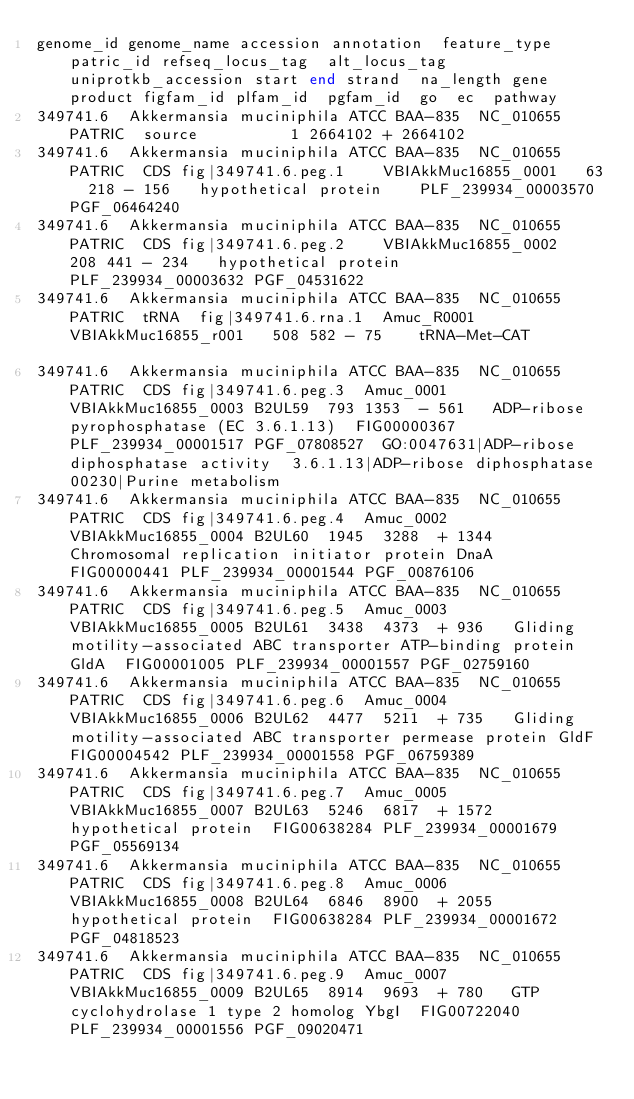<code> <loc_0><loc_0><loc_500><loc_500><_SQL_>genome_id	genome_name	accession	annotation	feature_type	patric_id	refseq_locus_tag	alt_locus_tag	uniprotkb_accession	start	end	strand	na_length	gene	product	figfam_id	plfam_id	pgfam_id	go	ec	pathway
349741.6	Akkermansia muciniphila ATCC BAA-835	NC_010655	PATRIC	source					1	2664102	+	2664102								
349741.6	Akkermansia muciniphila ATCC BAA-835	NC_010655	PATRIC	CDS	fig|349741.6.peg.1		VBIAkkMuc16855_0001		63	218	-	156		hypothetical protein		PLF_239934_00003570	PGF_06464240			
349741.6	Akkermansia muciniphila ATCC BAA-835	NC_010655	PATRIC	CDS	fig|349741.6.peg.2		VBIAkkMuc16855_0002		208	441	-	234		hypothetical protein		PLF_239934_00003632	PGF_04531622			
349741.6	Akkermansia muciniphila ATCC BAA-835	NC_010655	PATRIC	tRNA	fig|349741.6.rna.1	Amuc_R0001	VBIAkkMuc16855_r001		508	582	-	75		tRNA-Met-CAT						
349741.6	Akkermansia muciniphila ATCC BAA-835	NC_010655	PATRIC	CDS	fig|349741.6.peg.3	Amuc_0001	VBIAkkMuc16855_0003	B2UL59	793	1353	-	561		ADP-ribose pyrophosphatase (EC 3.6.1.13)	FIG00000367	PLF_239934_00001517	PGF_07808527	GO:0047631|ADP-ribose diphosphatase activity	3.6.1.13|ADP-ribose diphosphatase	00230|Purine metabolism
349741.6	Akkermansia muciniphila ATCC BAA-835	NC_010655	PATRIC	CDS	fig|349741.6.peg.4	Amuc_0002	VBIAkkMuc16855_0004	B2UL60	1945	3288	+	1344		Chromosomal replication initiator protein DnaA	FIG00000441	PLF_239934_00001544	PGF_00876106			
349741.6	Akkermansia muciniphila ATCC BAA-835	NC_010655	PATRIC	CDS	fig|349741.6.peg.5	Amuc_0003	VBIAkkMuc16855_0005	B2UL61	3438	4373	+	936		Gliding motility-associated ABC transporter ATP-binding protein GldA	FIG00001005	PLF_239934_00001557	PGF_02759160			
349741.6	Akkermansia muciniphila ATCC BAA-835	NC_010655	PATRIC	CDS	fig|349741.6.peg.6	Amuc_0004	VBIAkkMuc16855_0006	B2UL62	4477	5211	+	735		Gliding motility-associated ABC transporter permease protein GldF	FIG00004542	PLF_239934_00001558	PGF_06759389			
349741.6	Akkermansia muciniphila ATCC BAA-835	NC_010655	PATRIC	CDS	fig|349741.6.peg.7	Amuc_0005	VBIAkkMuc16855_0007	B2UL63	5246	6817	+	1572		hypothetical protein	FIG00638284	PLF_239934_00001679	PGF_05569134			
349741.6	Akkermansia muciniphila ATCC BAA-835	NC_010655	PATRIC	CDS	fig|349741.6.peg.8	Amuc_0006	VBIAkkMuc16855_0008	B2UL64	6846	8900	+	2055		hypothetical protein	FIG00638284	PLF_239934_00001672	PGF_04818523			
349741.6	Akkermansia muciniphila ATCC BAA-835	NC_010655	PATRIC	CDS	fig|349741.6.peg.9	Amuc_0007	VBIAkkMuc16855_0009	B2UL65	8914	9693	+	780		GTP cyclohydrolase 1 type 2 homolog YbgI	FIG00722040	PLF_239934_00001556	PGF_09020471			</code> 